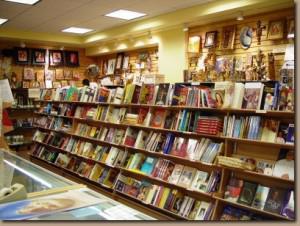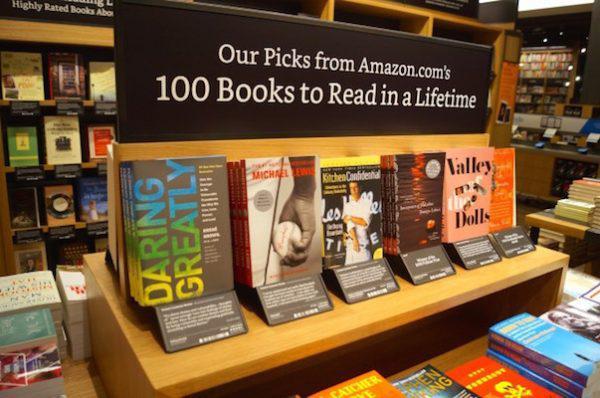The first image is the image on the left, the second image is the image on the right. Examine the images to the left and right. Is the description "In one image, wooden tables in the foreground of a bookstore are stacked with books for sale, with more books visible on the floor under or near the tables." accurate? Answer yes or no. No. The first image is the image on the left, the second image is the image on the right. For the images displayed, is the sentence "One bookstore interior shows central table displays flanked by empty aisles, and the other interior shows a table display with upright and flat books." factually correct? Answer yes or no. No. 